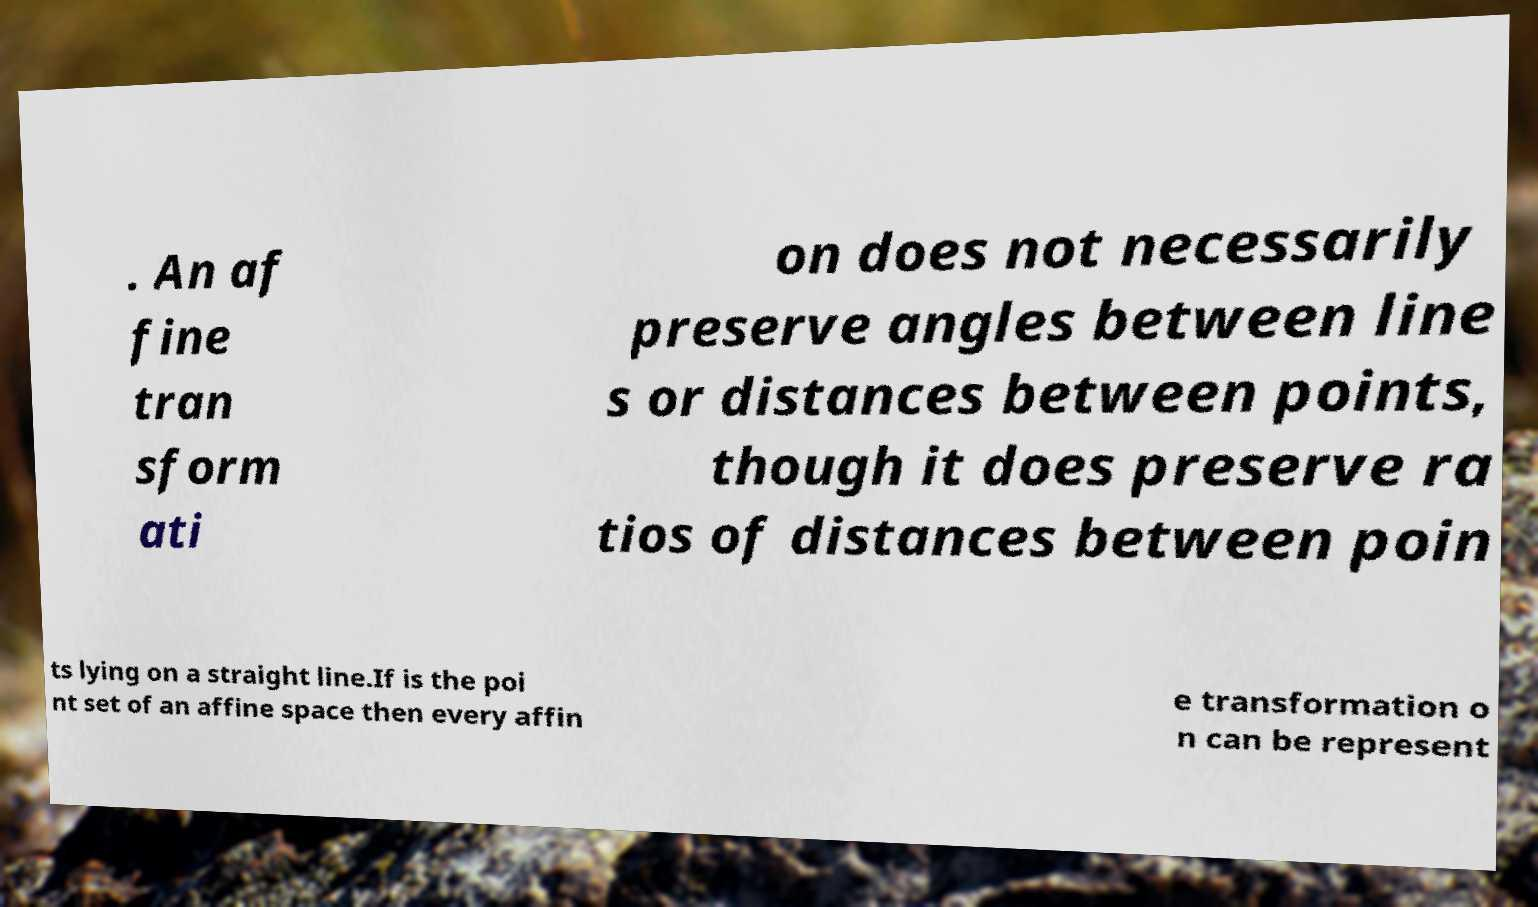For documentation purposes, I need the text within this image transcribed. Could you provide that? . An af fine tran sform ati on does not necessarily preserve angles between line s or distances between points, though it does preserve ra tios of distances between poin ts lying on a straight line.If is the poi nt set of an affine space then every affin e transformation o n can be represent 